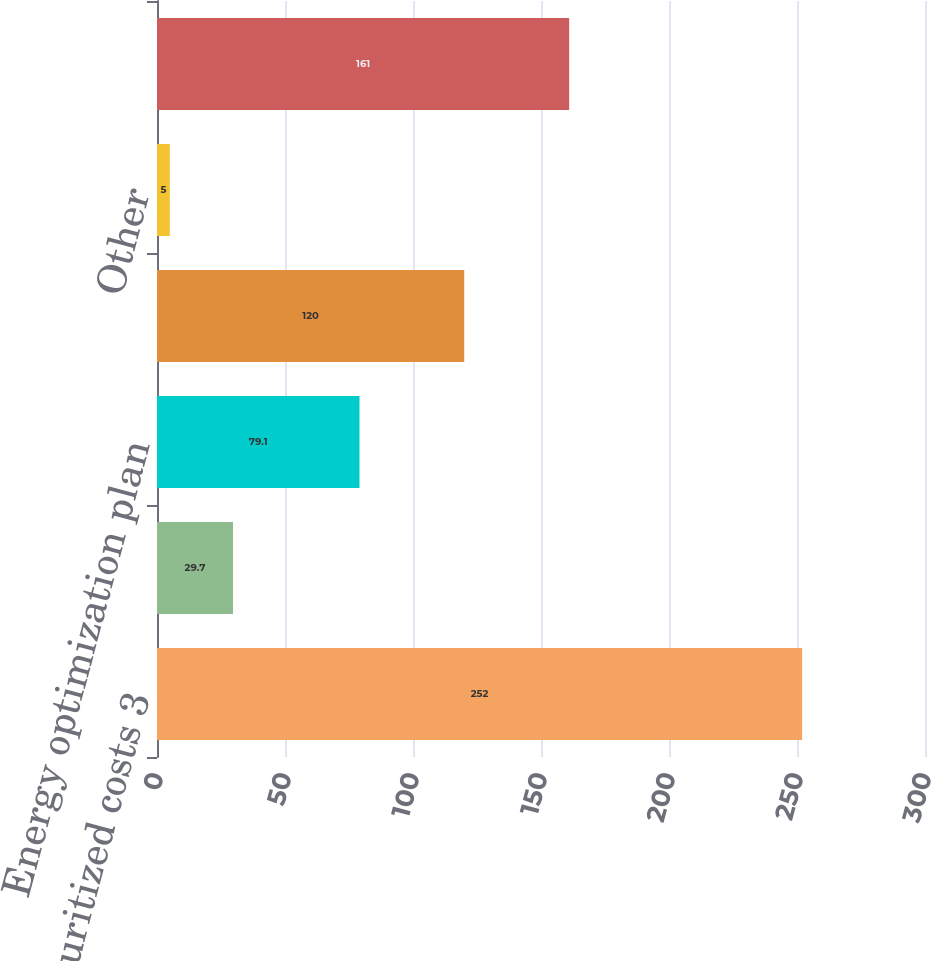Convert chart to OTSL. <chart><loc_0><loc_0><loc_500><loc_500><bar_chart><fcel>Securitized costs 3<fcel>Gas revenue decoupling<fcel>Energy optimization plan<fcel>DOE settlement<fcel>Other<fcel>Renewable energy plan<nl><fcel>252<fcel>29.7<fcel>79.1<fcel>120<fcel>5<fcel>161<nl></chart> 